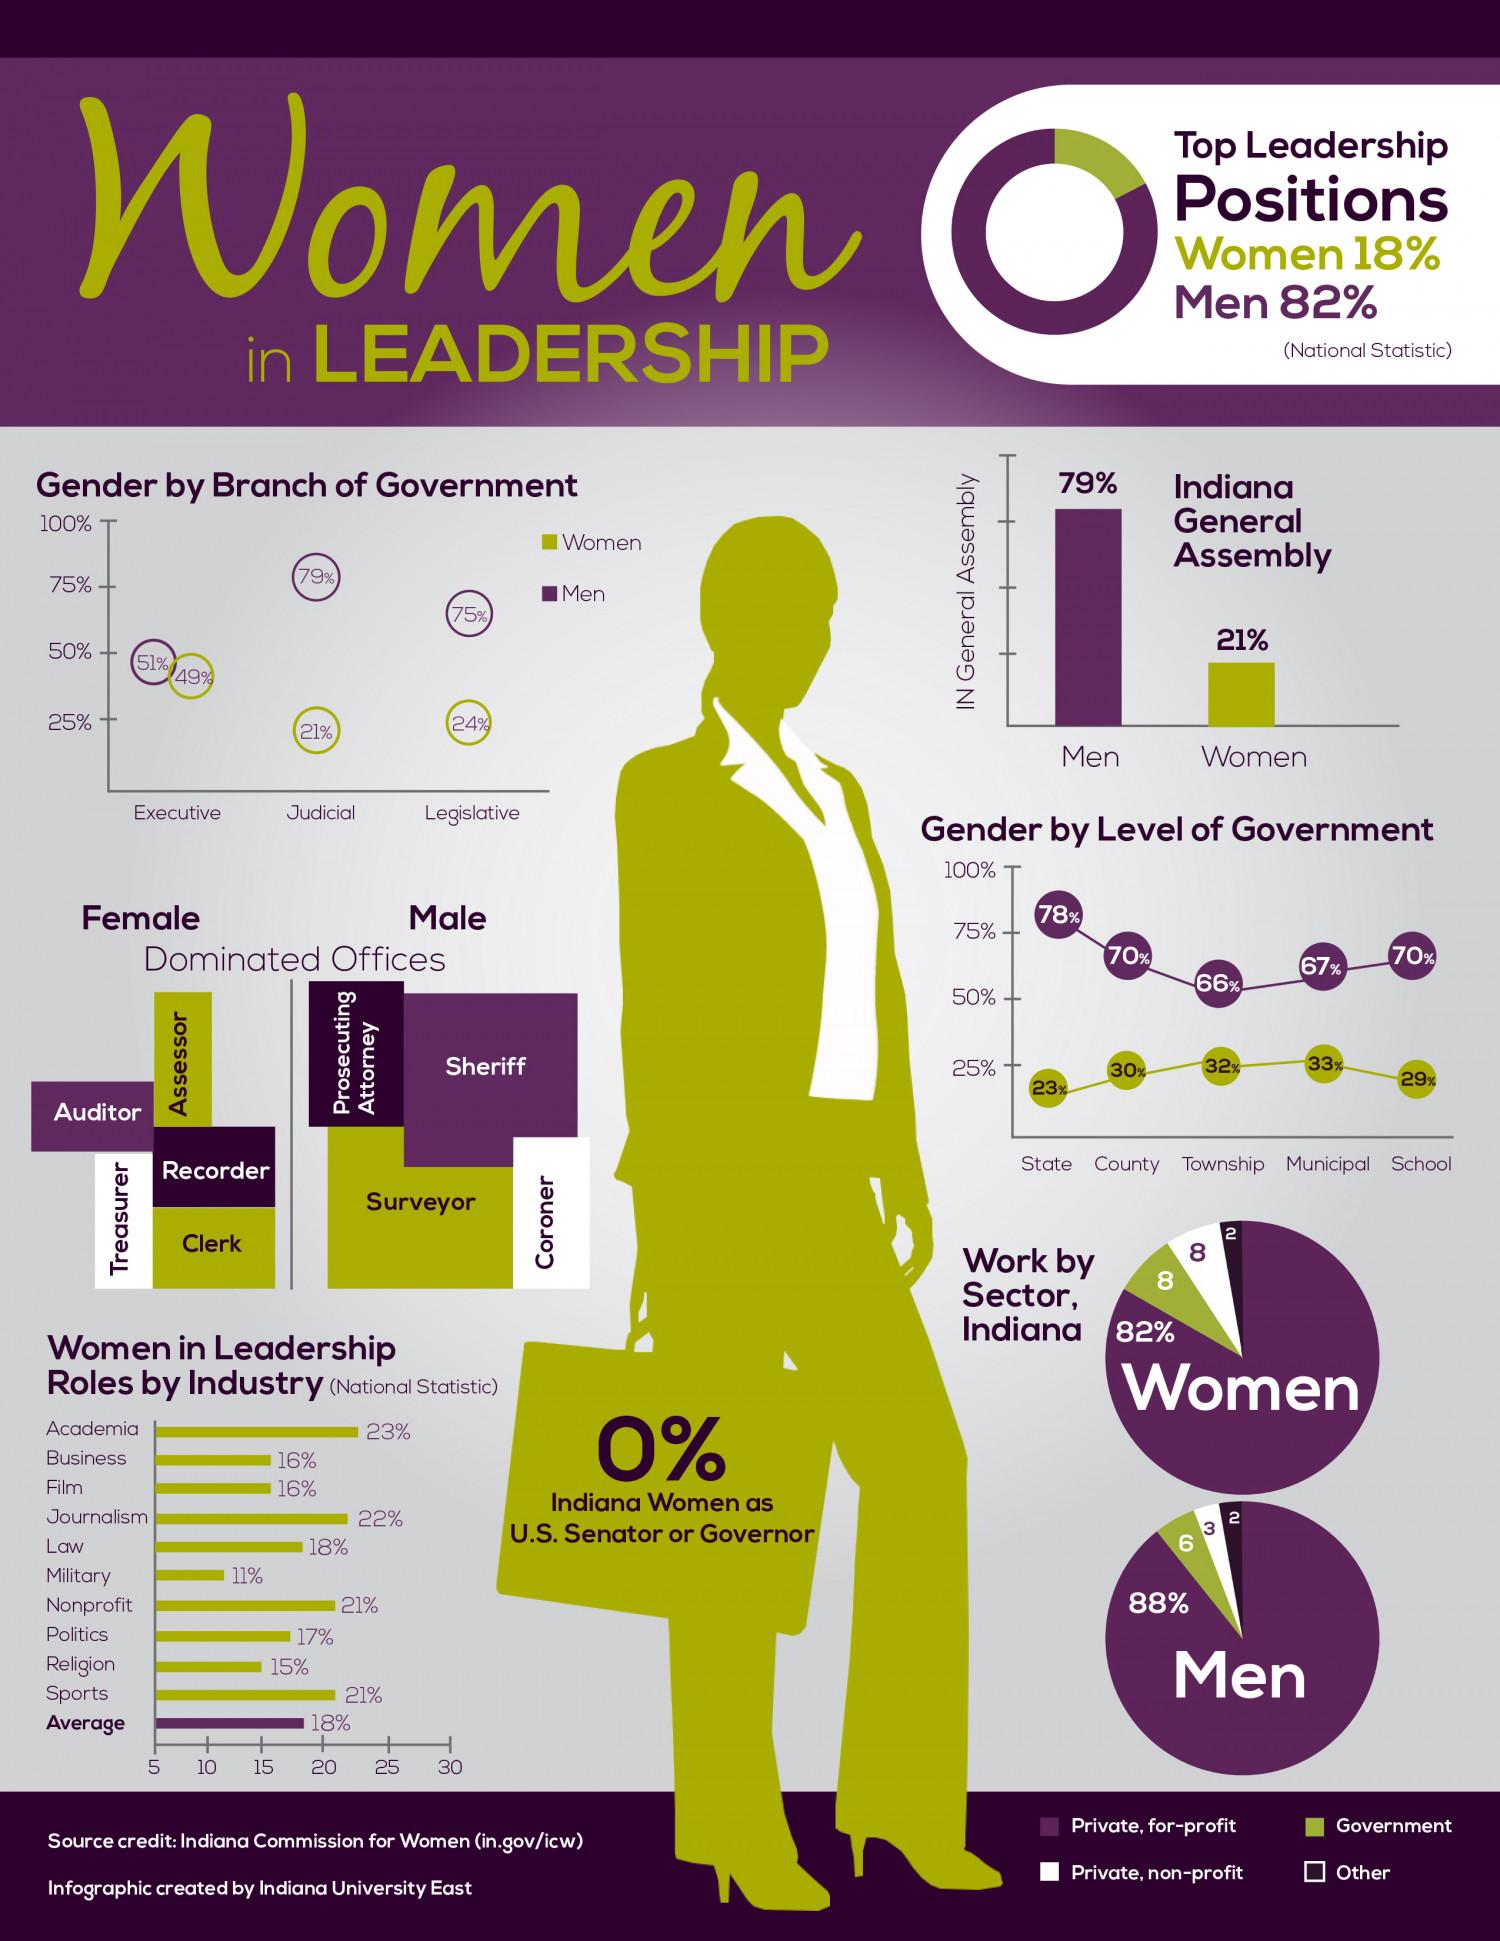Mention a couple of crucial points in this snapshot. According to data, only 29% of women hold leadership positions in both the law and military sectors. The executive and judicial branches of government are comprised of 70% women. There are 4 male-dominated offices. There are five female-dominated offices. The percentage of men in the executive and judicial branches of government is 130%. 